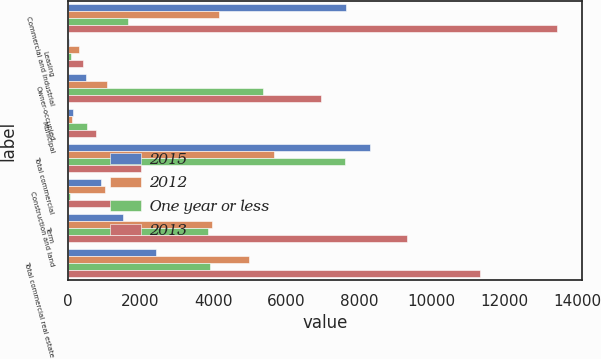<chart> <loc_0><loc_0><loc_500><loc_500><stacked_bar_chart><ecel><fcel>Commercial and industrial<fcel>Leasing<fcel>Owner-occupied<fcel>Municipal<fcel>Total commercial<fcel>Construction and land<fcel>Term<fcel>Total commercial real estate<nl><fcel>2015<fcel>7641<fcel>32<fcel>504<fcel>138<fcel>8315<fcel>921<fcel>1517<fcel>2438<nl><fcel>2012<fcel>4163<fcel>311<fcel>1078<fcel>121<fcel>5673<fcel>1031<fcel>3961<fcel>4992<nl><fcel>One year or less<fcel>1648<fcel>80<fcel>5380<fcel>519<fcel>7627<fcel>67<fcel>3844<fcel>3911<nl><fcel>2013<fcel>13452<fcel>423<fcel>6962<fcel>778<fcel>2019<fcel>2019<fcel>9322<fcel>11341<nl></chart> 